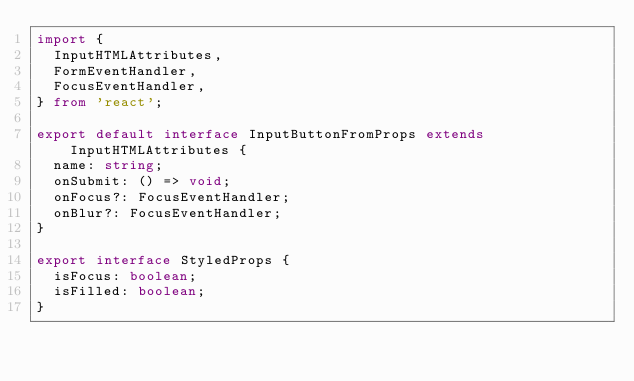Convert code to text. <code><loc_0><loc_0><loc_500><loc_500><_TypeScript_>import {
  InputHTMLAttributes,
  FormEventHandler,
  FocusEventHandler,
} from 'react';

export default interface InputButtonFromProps extends InputHTMLAttributes {
  name: string;
  onSubmit: () => void;
  onFocus?: FocusEventHandler;
  onBlur?: FocusEventHandler;
}

export interface StyledProps {
  isFocus: boolean;
  isFilled: boolean;
}
</code> 